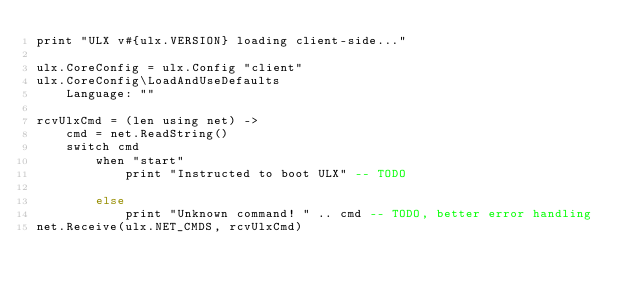<code> <loc_0><loc_0><loc_500><loc_500><_MoonScript_>print "ULX v#{ulx.VERSION} loading client-side..."

ulx.CoreConfig = ulx.Config "client"
ulx.CoreConfig\LoadAndUseDefaults
	Language: ""

rcvUlxCmd = (len using net) ->
	cmd = net.ReadString()
	switch cmd
		when "start"
			print "Instructed to boot ULX" -- TODO

		else
			print "Unknown command! " .. cmd -- TODO, better error handling
net.Receive(ulx.NET_CMDS, rcvUlxCmd)
</code> 